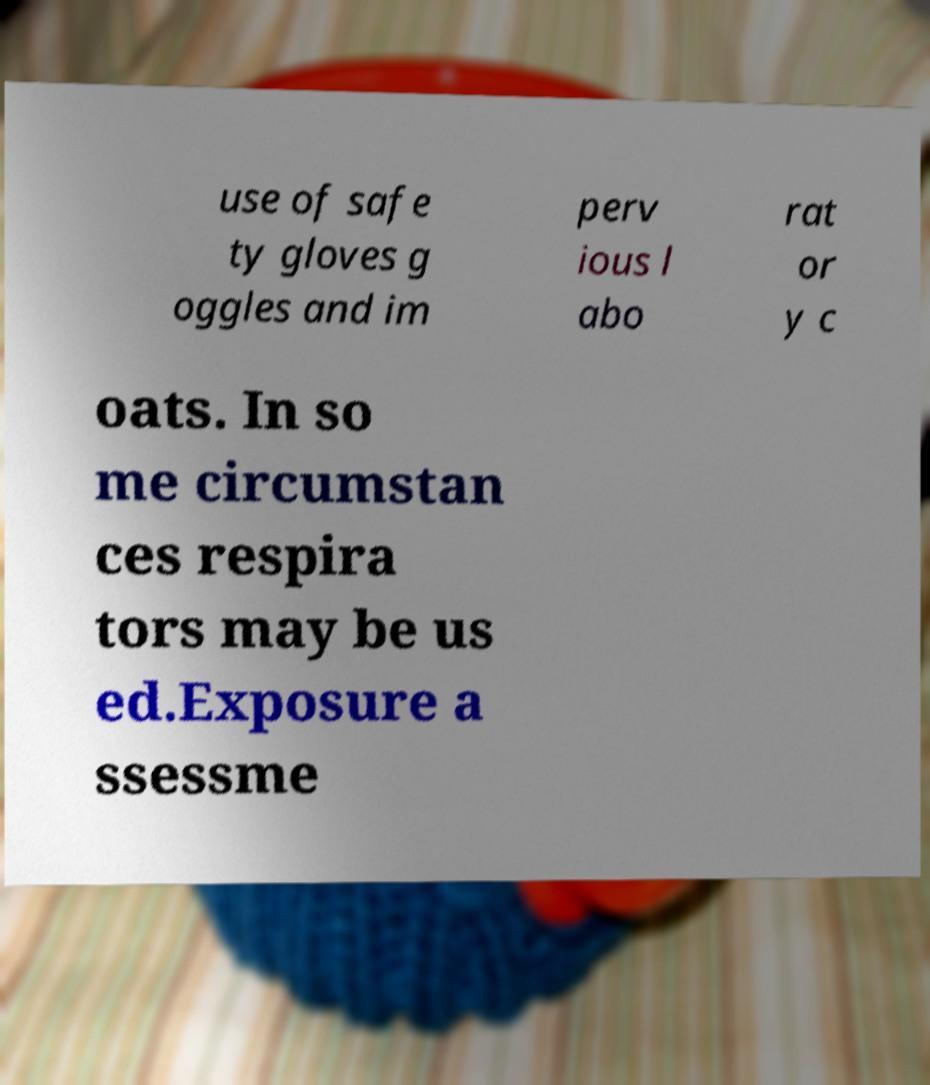Can you read and provide the text displayed in the image?This photo seems to have some interesting text. Can you extract and type it out for me? use of safe ty gloves g oggles and im perv ious l abo rat or y c oats. In so me circumstan ces respira tors may be us ed.Exposure a ssessme 